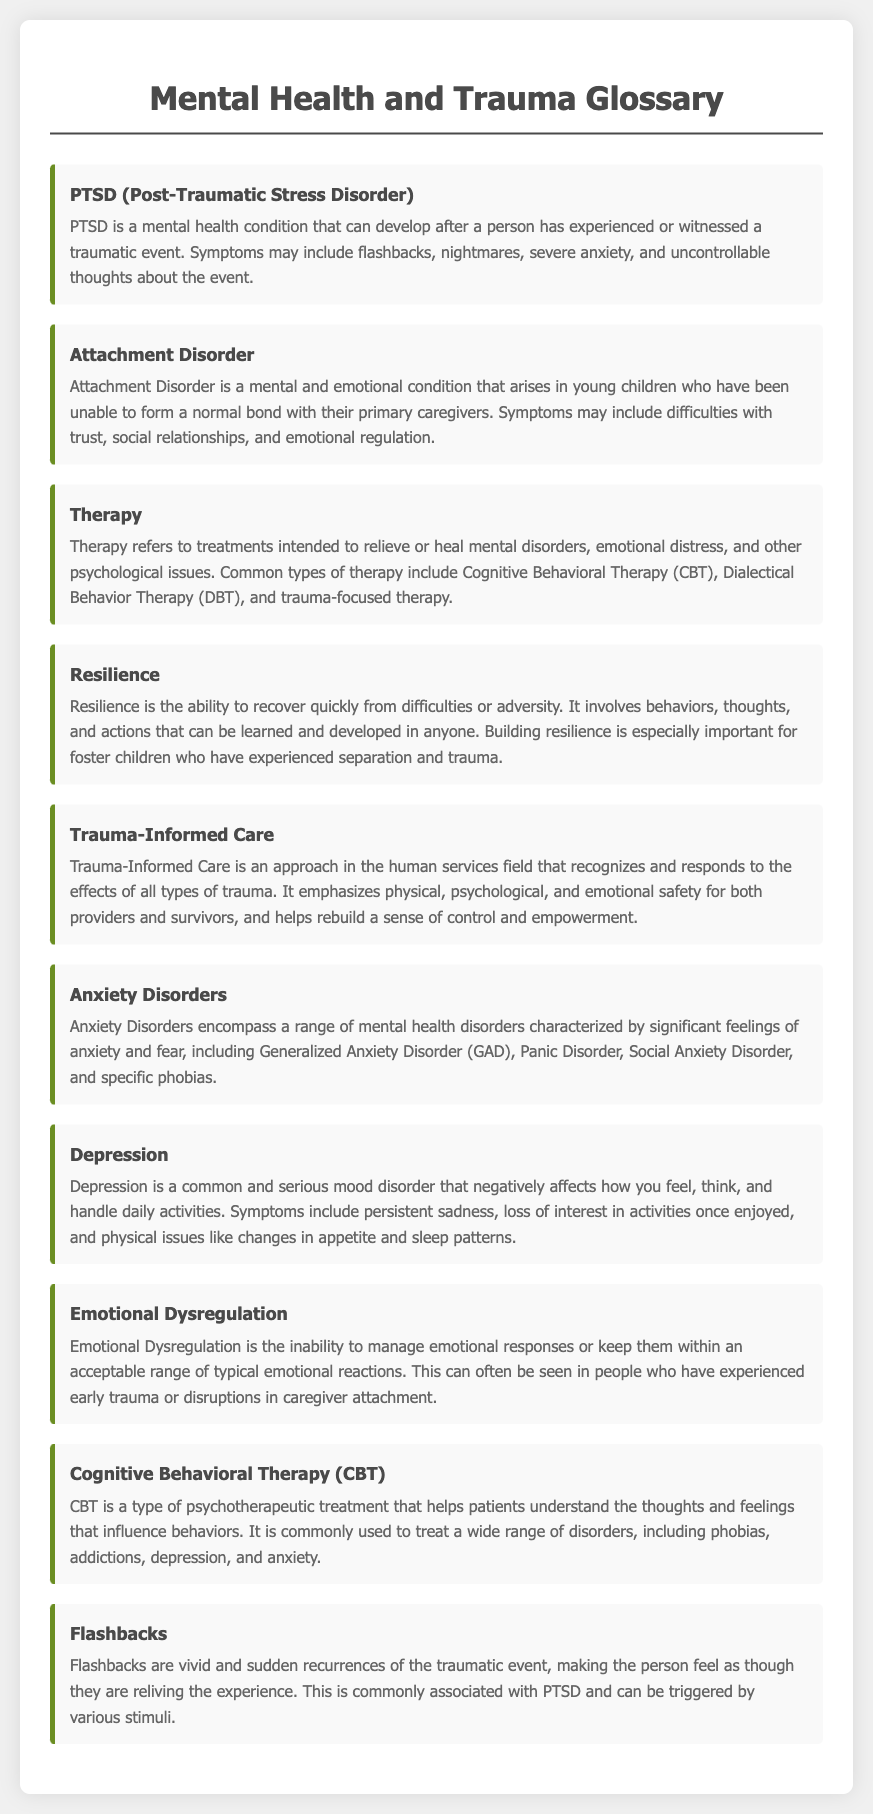What does PTSD stand for? PTSD is defined as an abbreviation in the glossary, specifically being "Post-Traumatic Stress Disorder."
Answer: Post-Traumatic Stress Disorder What is a symptom of PTSD? One symptom of PTSD mentioned in the glossary includes flashbacks, which are vivid recurrences of the traumatic event.
Answer: Flashbacks What type of therapy is commonly used to treat anxiety? The glossary includes Cognitive Behavioral Therapy (CBT) as a commonly used treatment for various disorders, including anxiety.
Answer: Cognitive Behavioral Therapy (CBT) What term describes the ability to recover quickly from difficulties? The glossary defines resilience as the ability to recover quickly from difficulties or adversity.
Answer: Resilience What does Trauma-Informed Care emphasize? The definition of Trauma-Informed Care in the glossary highlights the emphasis on physical, psychological, and emotional safety.
Answer: Physical, psychological, and emotional safety 